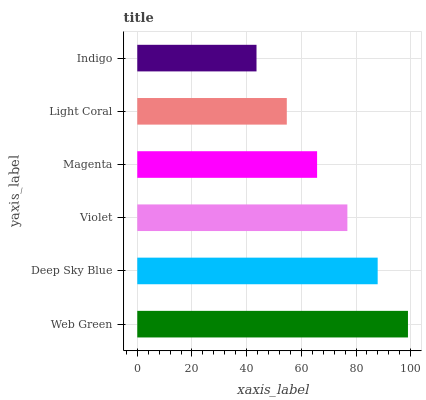Is Indigo the minimum?
Answer yes or no. Yes. Is Web Green the maximum?
Answer yes or no. Yes. Is Deep Sky Blue the minimum?
Answer yes or no. No. Is Deep Sky Blue the maximum?
Answer yes or no. No. Is Web Green greater than Deep Sky Blue?
Answer yes or no. Yes. Is Deep Sky Blue less than Web Green?
Answer yes or no. Yes. Is Deep Sky Blue greater than Web Green?
Answer yes or no. No. Is Web Green less than Deep Sky Blue?
Answer yes or no. No. Is Violet the high median?
Answer yes or no. Yes. Is Magenta the low median?
Answer yes or no. Yes. Is Deep Sky Blue the high median?
Answer yes or no. No. Is Light Coral the low median?
Answer yes or no. No. 